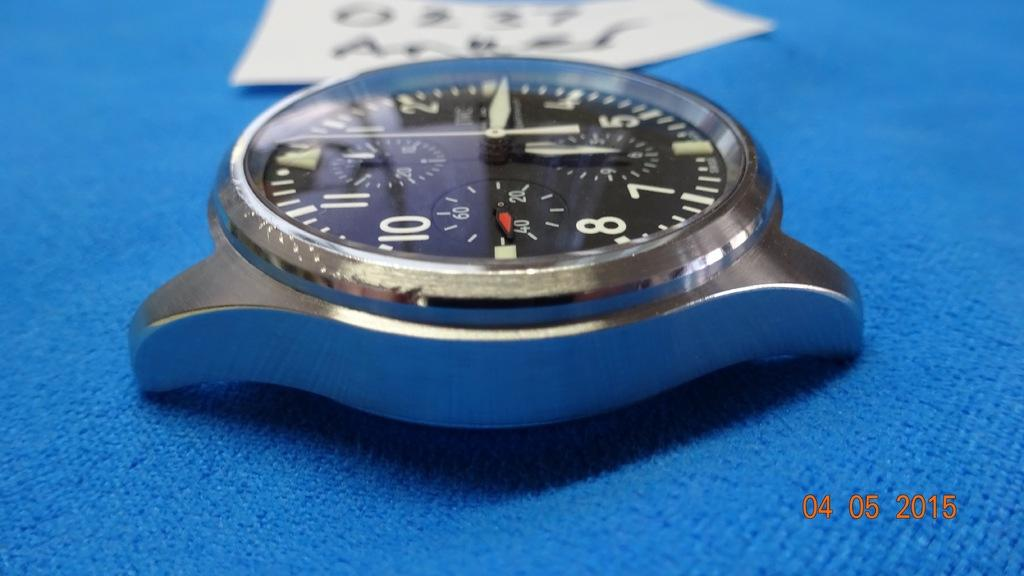<image>
Share a concise interpretation of the image provided. A watch displaying that the time is 6:15 